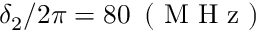<formula> <loc_0><loc_0><loc_500><loc_500>\delta _ { 2 } / 2 \pi = 8 0 \, ( M H z )</formula> 